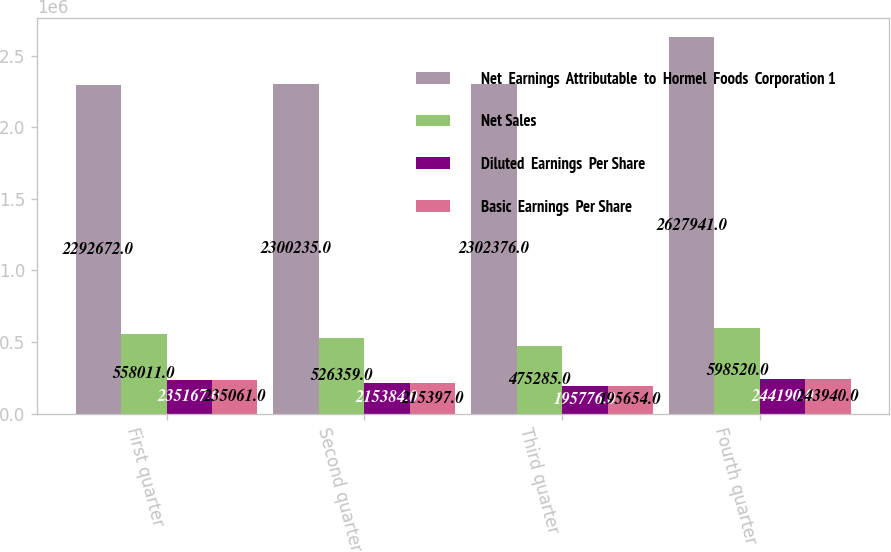Convert chart to OTSL. <chart><loc_0><loc_0><loc_500><loc_500><stacked_bar_chart><ecel><fcel>First quarter<fcel>Second quarter<fcel>Third quarter<fcel>Fourth quarter<nl><fcel>Net  Earnings  Attributable  to  Hormel  Foods  Corporation 1<fcel>2.29267e+06<fcel>2.30024e+06<fcel>2.30238e+06<fcel>2.62794e+06<nl><fcel>Net Sales<fcel>558011<fcel>526359<fcel>475285<fcel>598520<nl><fcel>Diluted  Earnings  Per Share<fcel>235167<fcel>215384<fcel>195776<fcel>244190<nl><fcel>Basic  Earnings  Per Share<fcel>235061<fcel>215397<fcel>195654<fcel>243940<nl></chart> 